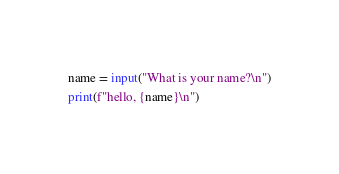<code> <loc_0><loc_0><loc_500><loc_500><_Python_>name = input("What is your name?\n")
print(f"hello, {name}\n")</code> 